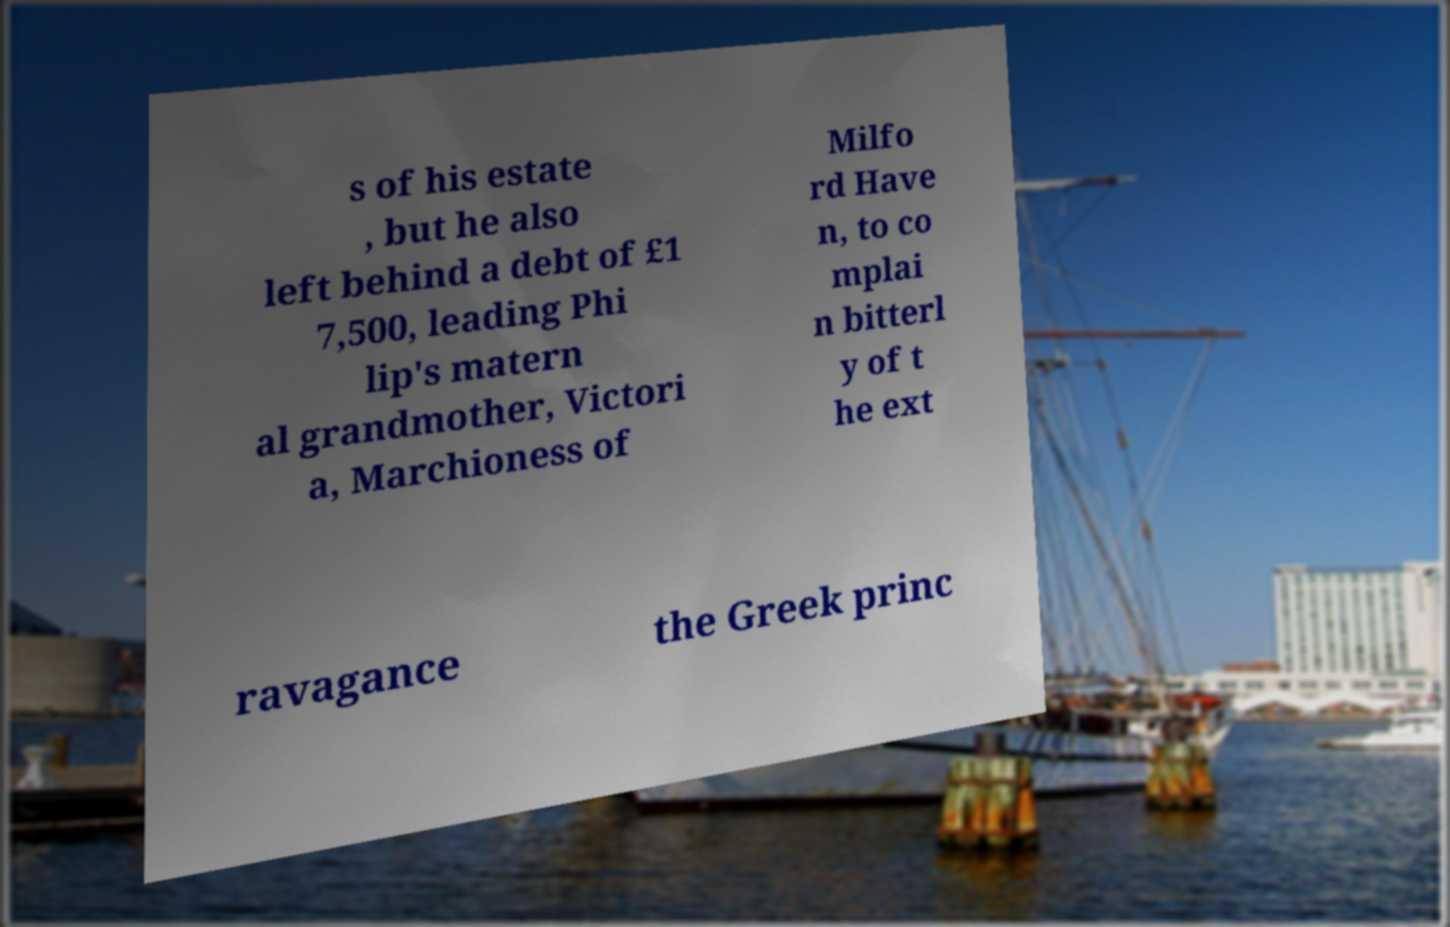Could you assist in decoding the text presented in this image and type it out clearly? s of his estate , but he also left behind a debt of £1 7,500, leading Phi lip's matern al grandmother, Victori a, Marchioness of Milfo rd Have n, to co mplai n bitterl y of t he ext ravagance the Greek princ 